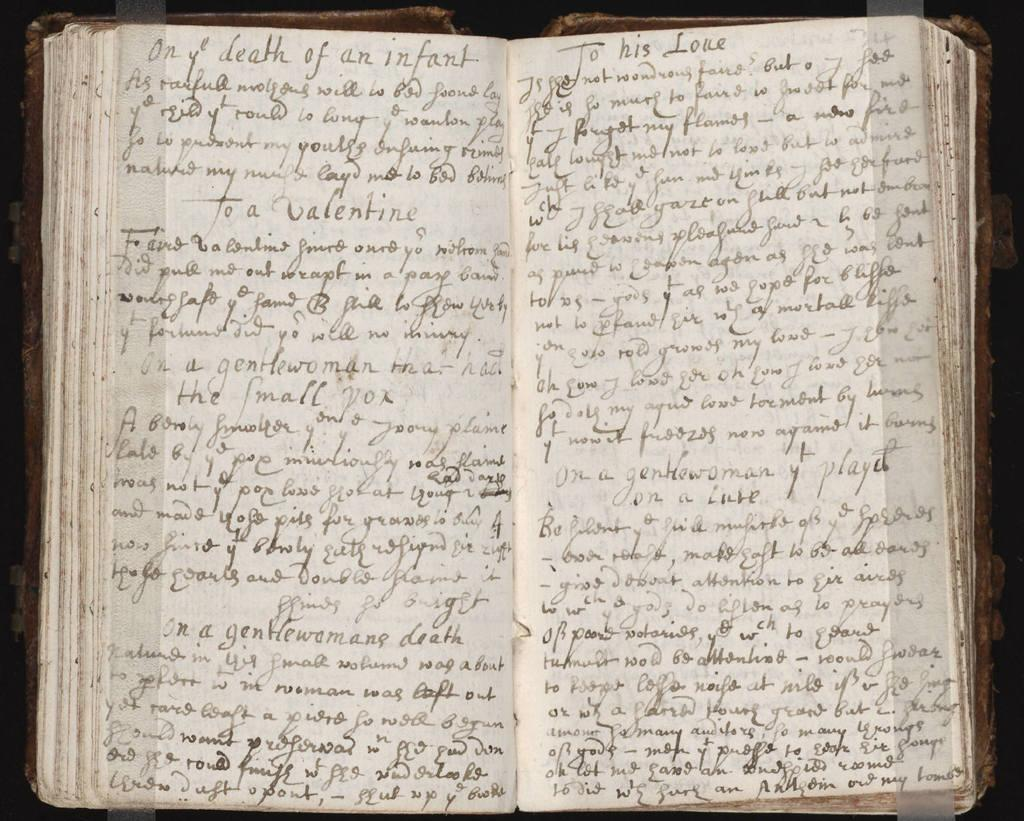<image>
Present a compact description of the photo's key features. an open book or journal with handwritten pages that has words death of an infant at top of left page 